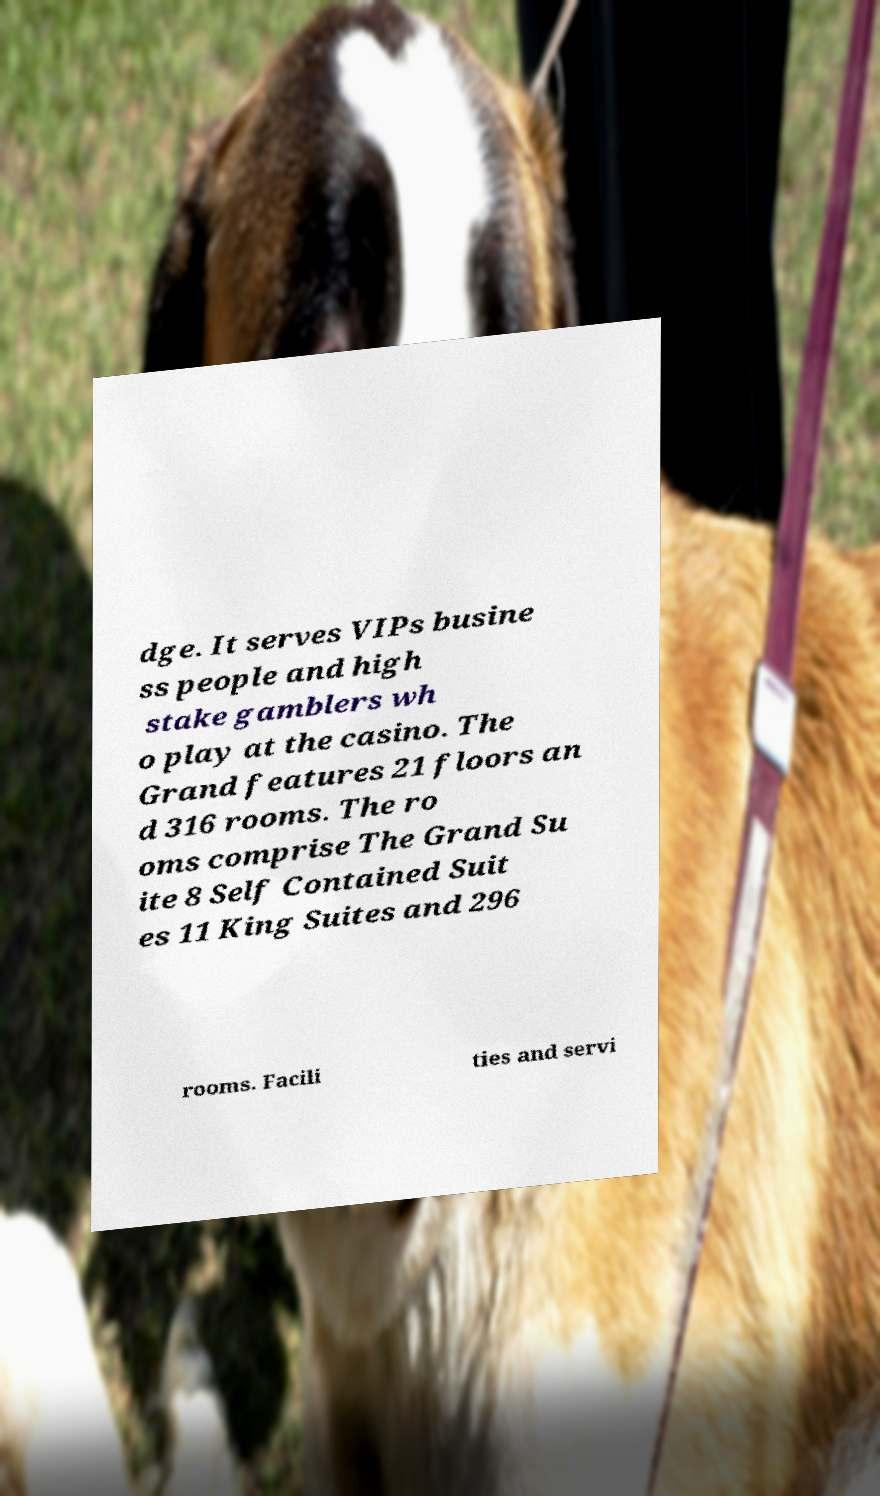Could you extract and type out the text from this image? dge. It serves VIPs busine ss people and high stake gamblers wh o play at the casino. The Grand features 21 floors an d 316 rooms. The ro oms comprise The Grand Su ite 8 Self Contained Suit es 11 King Suites and 296 rooms. Facili ties and servi 